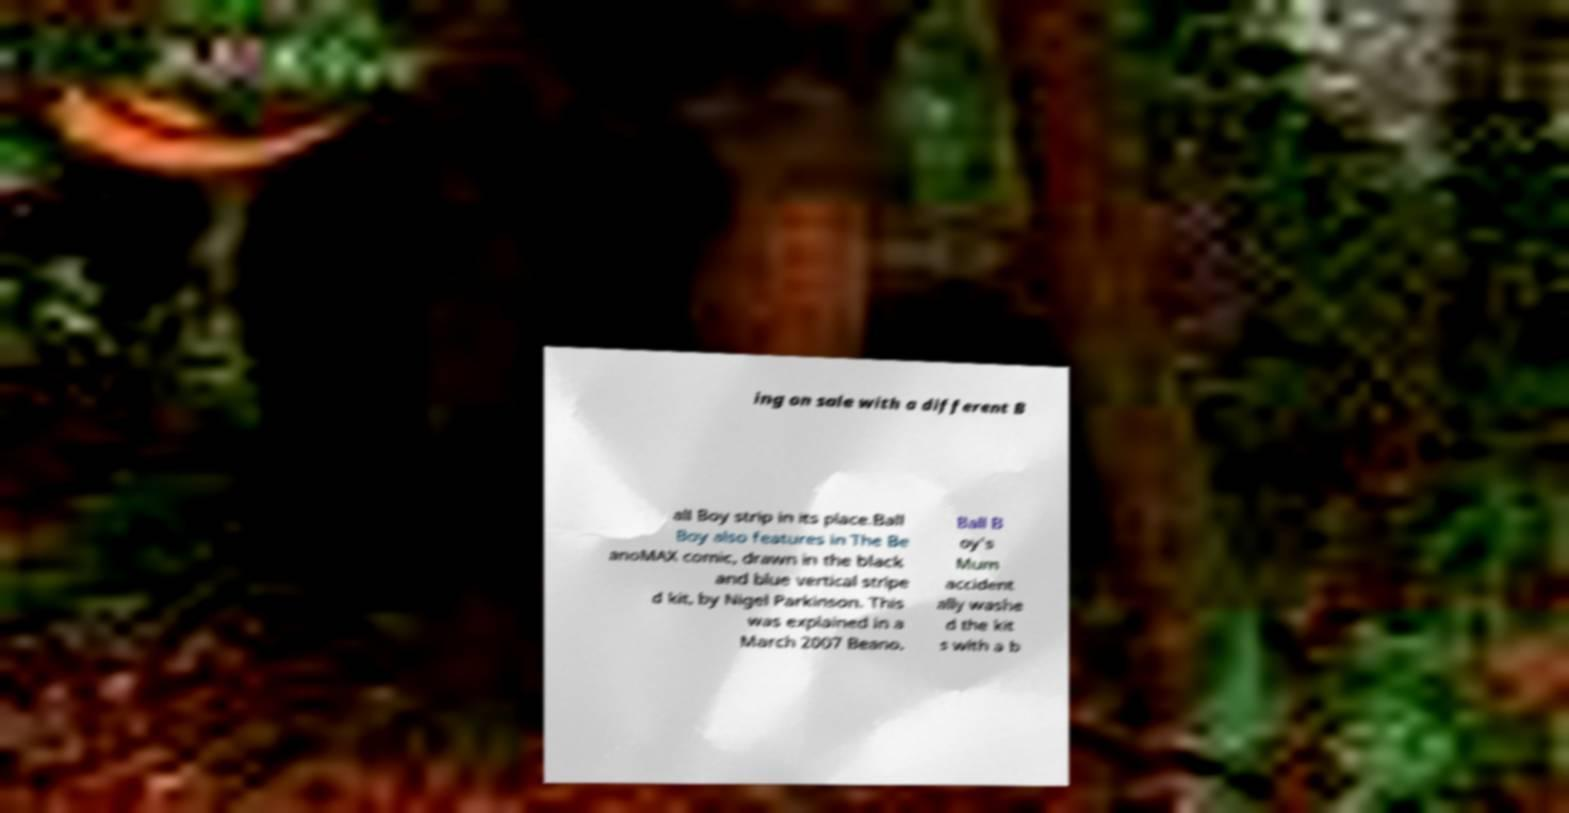I need the written content from this picture converted into text. Can you do that? ing on sale with a different B all Boy strip in its place.Ball Boy also features in The Be anoMAX comic, drawn in the black and blue vertical stripe d kit, by Nigel Parkinson. This was explained in a March 2007 Beano. Ball B oy's Mum accident ally washe d the kit s with a b 